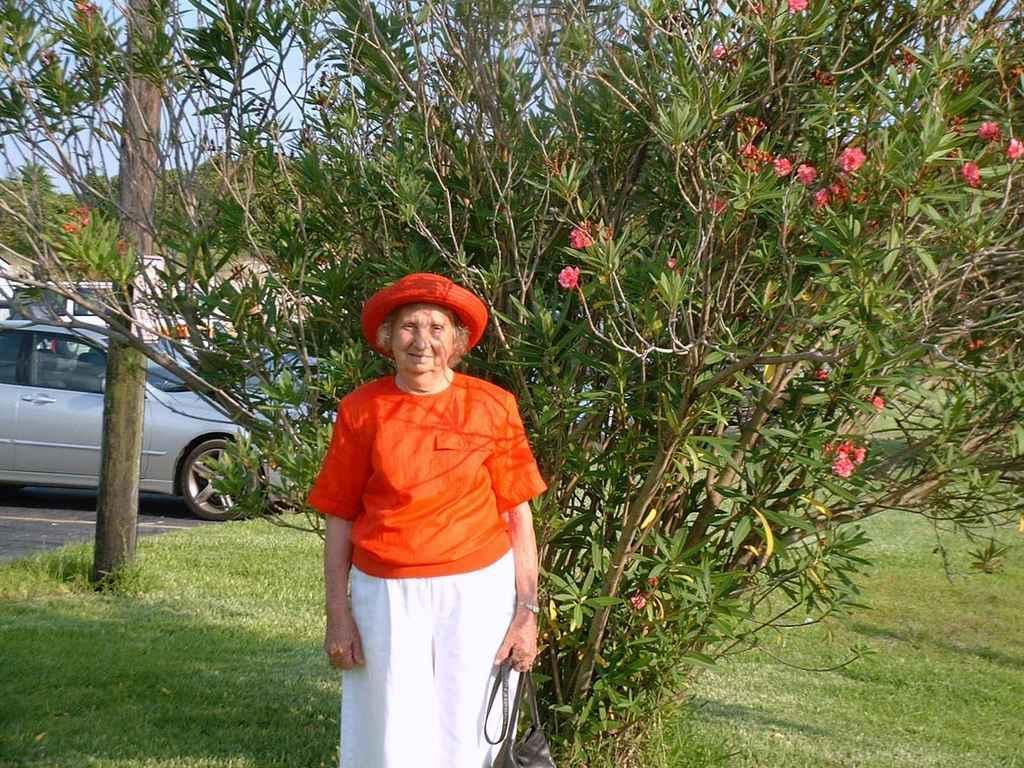In one or two sentences, can you explain what this image depicts? In this image, we can see an old lady is holding a bag and wearing a hat. She is smiling and seeing. Background we can see trees, flowers, grass, vehicles and sky. 